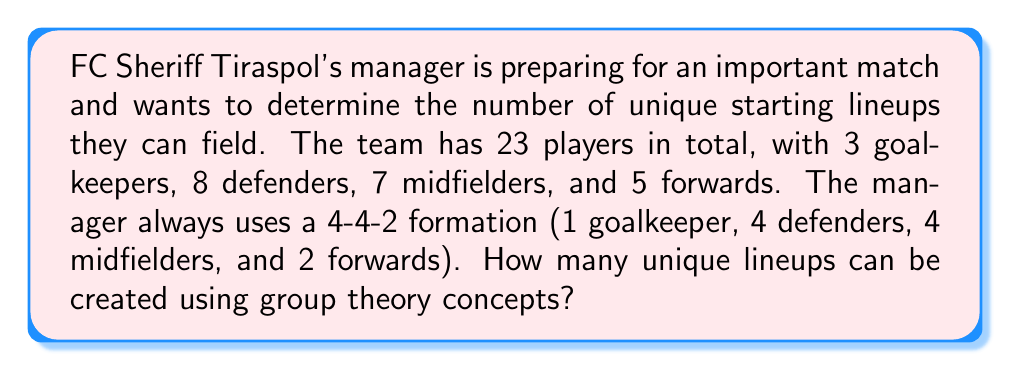What is the answer to this math problem? To solve this problem, we can use the concept of permutations from group theory. We'll break down the solution into steps:

1. First, let's consider each position group separately:
   - Goalkeepers: We need to choose 1 out of 3
   - Defenders: We need to choose 4 out of 8
   - Midfielders: We need to choose 4 out of 7
   - Forwards: We need to choose 2 out of 5

2. For each group, we can use the combination formula:
   $${n \choose k} = \frac{n!}{k!(n-k)!}$$

3. Let's calculate each combination:
   - Goalkeepers: $${3 \choose 1} = \frac{3!}{1!(3-1)!} = 3$$
   - Defenders: $${8 \choose 4} = \frac{8!}{4!(8-4)!} = 70$$
   - Midfielders: $${7 \choose 4} = \frac{7!}{4!(7-4)!} = 35$$
   - Forwards: $${5 \choose 2} = \frac{5!}{2!(5-2)!} = 10$$

4. Now, we can use the multiplication principle from group theory. The total number of unique lineups is the product of all possible combinations for each position:

   $$\text{Total lineups} = 3 \times 70 \times 35 \times 10$$

5. Calculate the final result:
   $$\text{Total lineups} = 3 \times 70 \times 35 \times 10 = 73,500$$

Therefore, FC Sheriff Tiraspol's manager can create 73,500 unique lineups using the 4-4-2 formation.
Answer: 73,500 unique lineups 